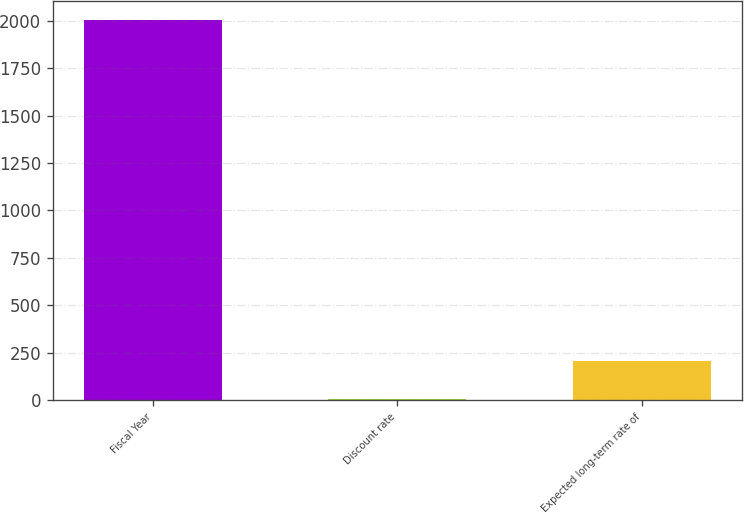<chart> <loc_0><loc_0><loc_500><loc_500><bar_chart><fcel>Fiscal Year<fcel>Discount rate<fcel>Expected long-term rate of<nl><fcel>2003<fcel>7.5<fcel>207.05<nl></chart> 